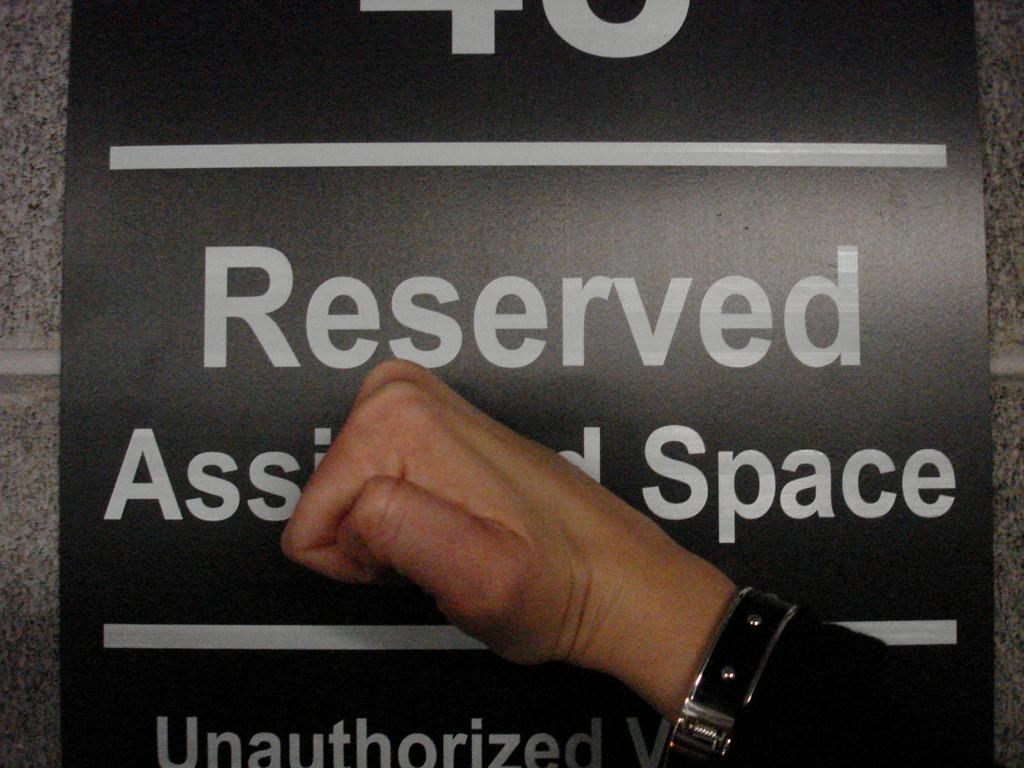Is the area this sign refers to a reserved area?
Keep it short and to the point. Yes. What word is displayed to the right of the man's fist?
Offer a terse response. Space. 